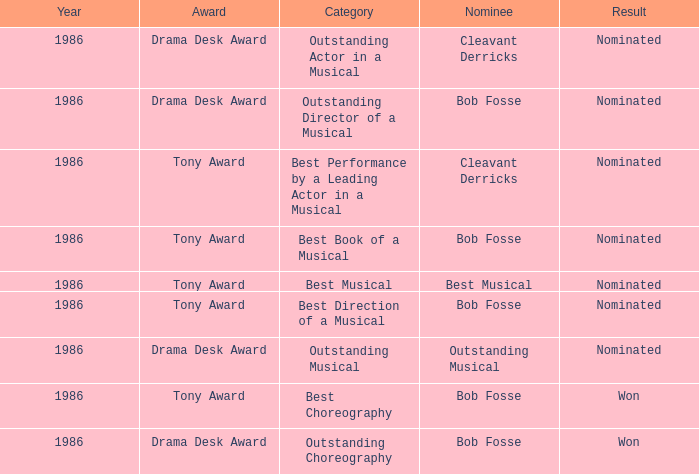Which award has the category of the best direction of a musical? Tony Award. 